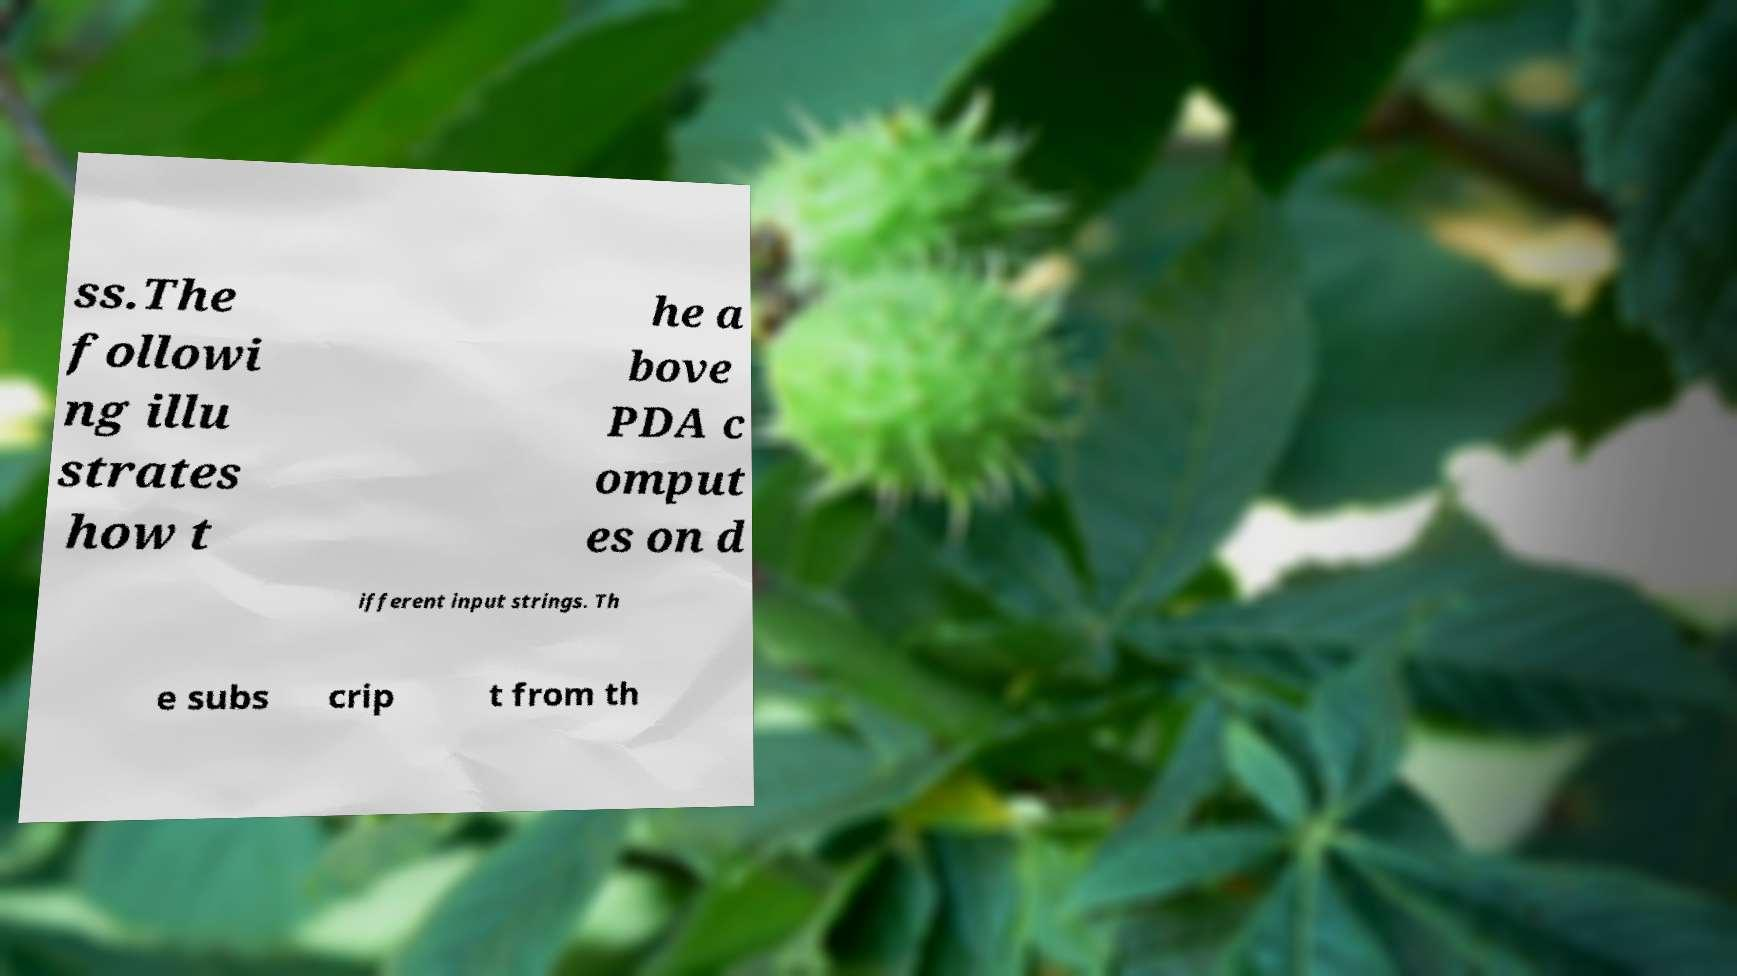I need the written content from this picture converted into text. Can you do that? ss.The followi ng illu strates how t he a bove PDA c omput es on d ifferent input strings. Th e subs crip t from th 